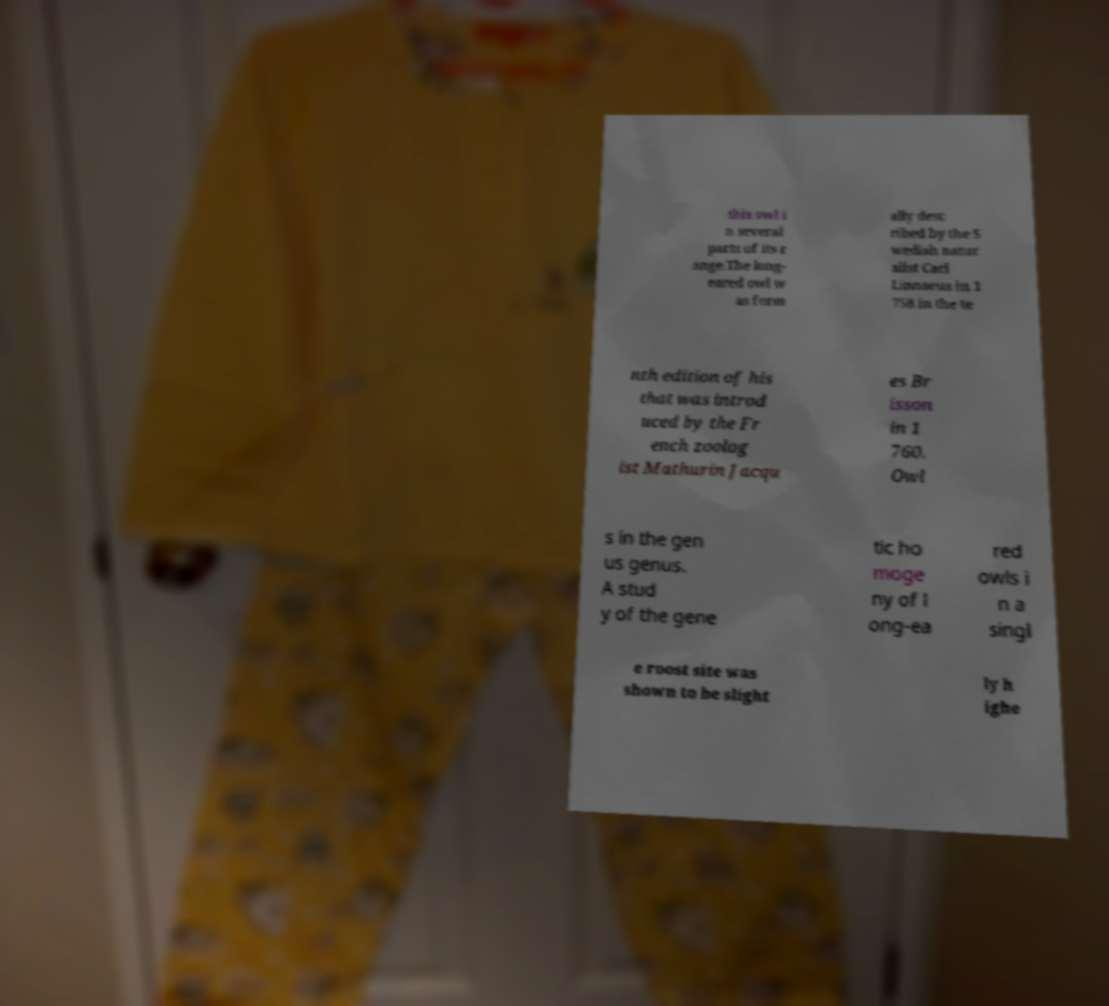There's text embedded in this image that I need extracted. Can you transcribe it verbatim? this owl i n several parts of its r ange.The long- eared owl w as form ally desc ribed by the S wedish natur alist Carl Linnaeus in 1 758 in the te nth edition of his that was introd uced by the Fr ench zoolog ist Mathurin Jacqu es Br isson in 1 760. Owl s in the gen us genus. A stud y of the gene tic ho moge ny of l ong-ea red owls i n a singl e roost site was shown to be slight ly h ighe 